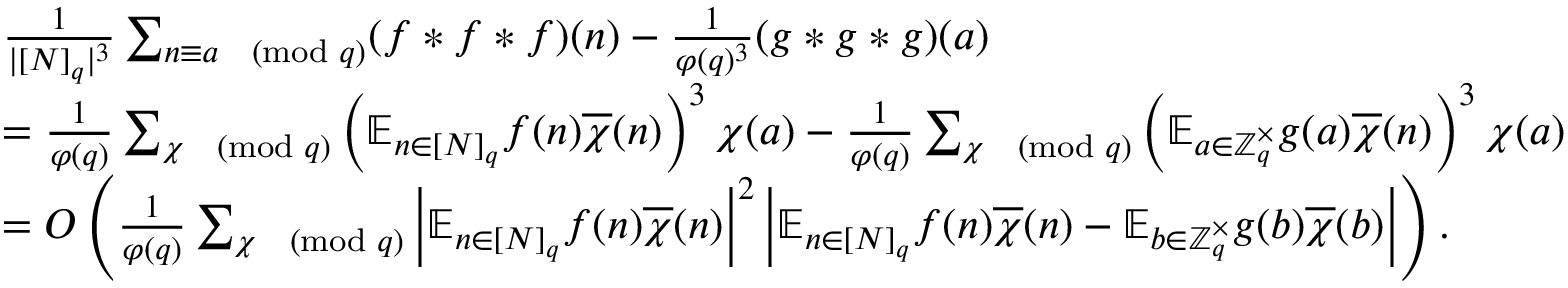<formula> <loc_0><loc_0><loc_500><loc_500>\begin{array} { r } { \begin{array} { r l } & { \frac { 1 } { | [ N ] _ { q } | ^ { 3 } } \sum _ { n \equiv a \pmod { q } } ( f \ast f \ast f ) ( n ) - \frac { 1 } { \varphi ( q ) ^ { 3 } } ( g \ast g \ast g ) ( a ) } \\ & { = \frac { 1 } { \varphi ( q ) } \sum _ { \chi \pmod { q } } \left ( \mathbb { E } _ { n \in [ N ] _ { q } } f ( n ) \overline { \chi } ( n ) \right ) ^ { 3 } \chi ( a ) - \frac { 1 } { \varphi ( q ) } \sum _ { \chi \pmod { q } } \left ( \mathbb { E } _ { a \in \mathbb { Z } _ { q } ^ { \times } } g ( a ) \overline { \chi } ( n ) \right ) ^ { 3 } \chi ( a ) } \\ & { = O \left ( \frac { 1 } { \varphi ( q ) } \sum _ { \chi \pmod { q } } \left | \mathbb { E } _ { n \in [ N ] _ { q } } f ( n ) \overline { \chi } ( n ) \right | ^ { 2 } \left | \mathbb { E } _ { n \in [ N ] _ { q } } f ( n ) \overline { \chi } ( n ) - \mathbb { E } _ { b \in \mathbb { Z } _ { q } ^ { \times } } g ( b ) \overline { \chi } ( b ) \right | \right ) . } \end{array} } \end{array}</formula> 